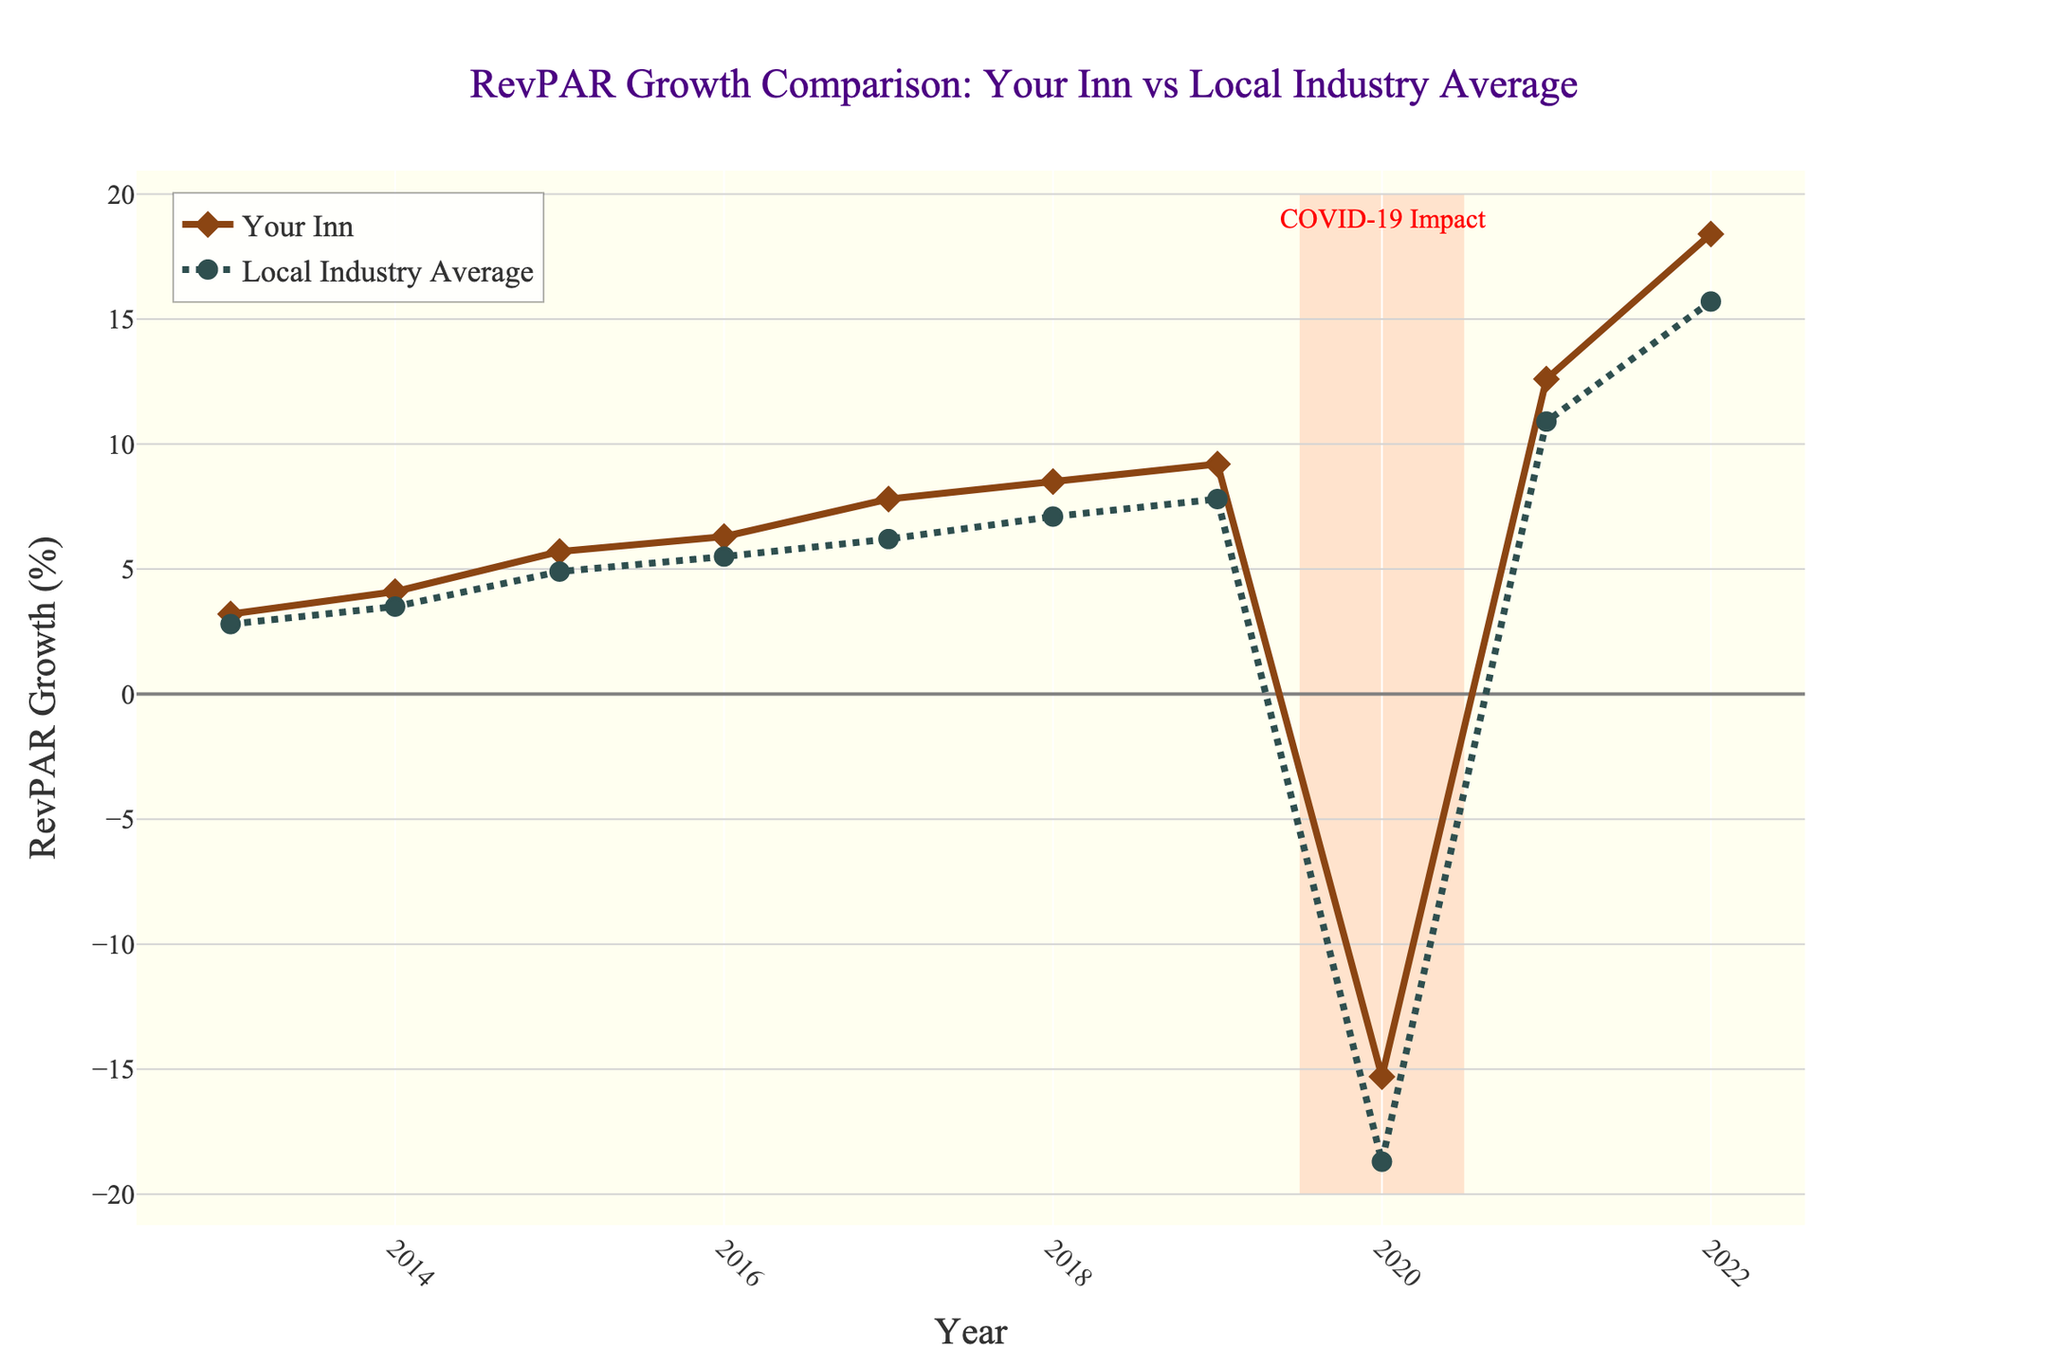How did the growth rate of Your Inn compare to the local industry average in 2021? To compare the growth rates in 2021, identify the RevPAR growth value for Your Inn and the local industry average in that year. Your Inn had a growth rate of 12.6%, while the local industry average was 10.9%.
Answer: Your Inn had higher growth During which year did Your Inn experience the highest RevPAR growth, and what was the value? Look at the year with the highest point on the "Your Inn" line to find the peak value. The highest RevPAR growth occurred in 2022, with a value of 18.4%.
Answer: 2022, 18.4% How does the drop in RevPAR growth during 2020 for Your Inn compare to the local industry average? For 2020, note the RevPAR growth values for both Your Inn and the local industry average. Your Inn experienced a -15.3% growth, while the local industry average had -18.7%. Comparing these values shows that Your Inn had a smaller drop than the local industry average.
Answer: Smaller drop What was the difference in RevPAR growth between Your Inn and the local industry average in 2019? Identify the RevPAR growth values in 2019 for both Your Inn and the local industry average. Your Inn had a 9.2% growth, and the local industry average was 7.8%. The difference is 9.2% - 7.8% = 1.4%.
Answer: 1.4% What visual element indicates the impact of COVID-19 on the chart, and what years does it cover? Look for any special shapes, colors, or annotations on the chart that denote COVID-19 impact. A light salmon rectangle highlights the COVID-19 impact, covering from the end of 2019 through 2020.
Answer: Light salmon rectangle, 2019-2020 Which year showed a closer alignment in RevPAR growth between Your Inn and the local industry average? Examine the lines to find a year where the values of RevPAR growth for Your Inn and the local industry average are close together. In 2016, Your Inn had a 6.3% growth and the local industry average was 5.5%, showing closer alignment compared to other years.
Answer: 2016 Calculate the average RevPAR growth for Your Inn over the given period, excluding 2020. Exclude 2020 and sum the growth rates for Your Inn over the remaining years: (3.2 + 4.1 + 5.7 + 6.3 + 7.8 + 8.5 + 9.2 + 12.6 + 18.4). Dividing this total by the number of years (9), we get the average.
Answer: 8.4% How did the trends in RevPAR growth from 2013 to 2018 compare between Your Inn and the local industry average? Observe the lines from 2013 to 2018. Both lines show an upward trend, with Your Inn consistently experiencing higher growth rates each year compared to the local industry average.
Answer: Both upward, Your Inn higher Which line uses markers in a diamond shape, and what does it represent? Identify the shape used for the markers on each line in the chart. The line with diamond markers represents "Your Inn RevPAR Growth (%)".
Answer: Your Inn What is the overall trend in RevPAR growth for Your Inn from 2013 to 2022, and how does it compare to the local industry average? Assess the entire period from 2013 to 2022. Both lines generally trend upward, ignore the dip in 2020 due to COVID-19. However, Your Inn shows a steeper upward trend compared to the local industry average.
Answer: Both upward, Your Inn steeper 